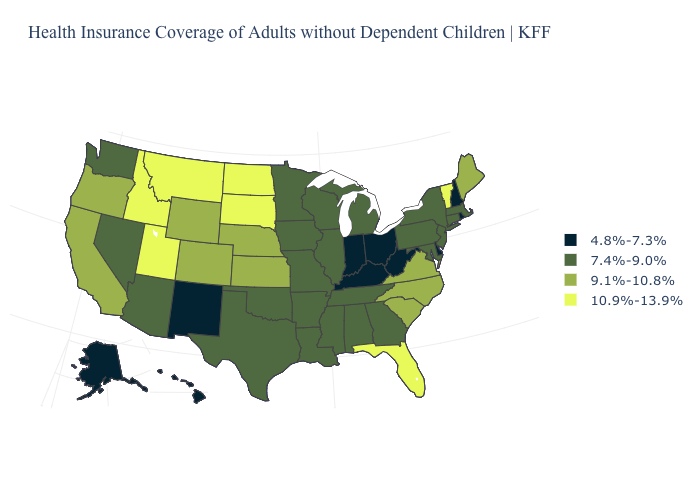What is the value of New Hampshire?
Concise answer only. 4.8%-7.3%. Does the first symbol in the legend represent the smallest category?
Give a very brief answer. Yes. What is the value of Louisiana?
Give a very brief answer. 7.4%-9.0%. Among the states that border Kansas , does Oklahoma have the highest value?
Short answer required. No. Does Florida have the same value as Maryland?
Concise answer only. No. What is the highest value in states that border New York?
Short answer required. 10.9%-13.9%. Name the states that have a value in the range 9.1%-10.8%?
Give a very brief answer. California, Colorado, Kansas, Maine, Nebraska, North Carolina, Oregon, South Carolina, Virginia, Wyoming. Name the states that have a value in the range 7.4%-9.0%?
Short answer required. Alabama, Arizona, Arkansas, Connecticut, Georgia, Illinois, Iowa, Louisiana, Maryland, Massachusetts, Michigan, Minnesota, Mississippi, Missouri, Nevada, New Jersey, New York, Oklahoma, Pennsylvania, Tennessee, Texas, Washington, Wisconsin. Does Vermont have the lowest value in the Northeast?
Answer briefly. No. What is the highest value in the USA?
Keep it brief. 10.9%-13.9%. What is the value of Wisconsin?
Write a very short answer. 7.4%-9.0%. Which states have the lowest value in the West?
Write a very short answer. Alaska, Hawaii, New Mexico. Does South Dakota have a higher value than Pennsylvania?
Answer briefly. Yes. Does Oregon have the highest value in the West?
Keep it brief. No. Name the states that have a value in the range 10.9%-13.9%?
Keep it brief. Florida, Idaho, Montana, North Dakota, South Dakota, Utah, Vermont. 